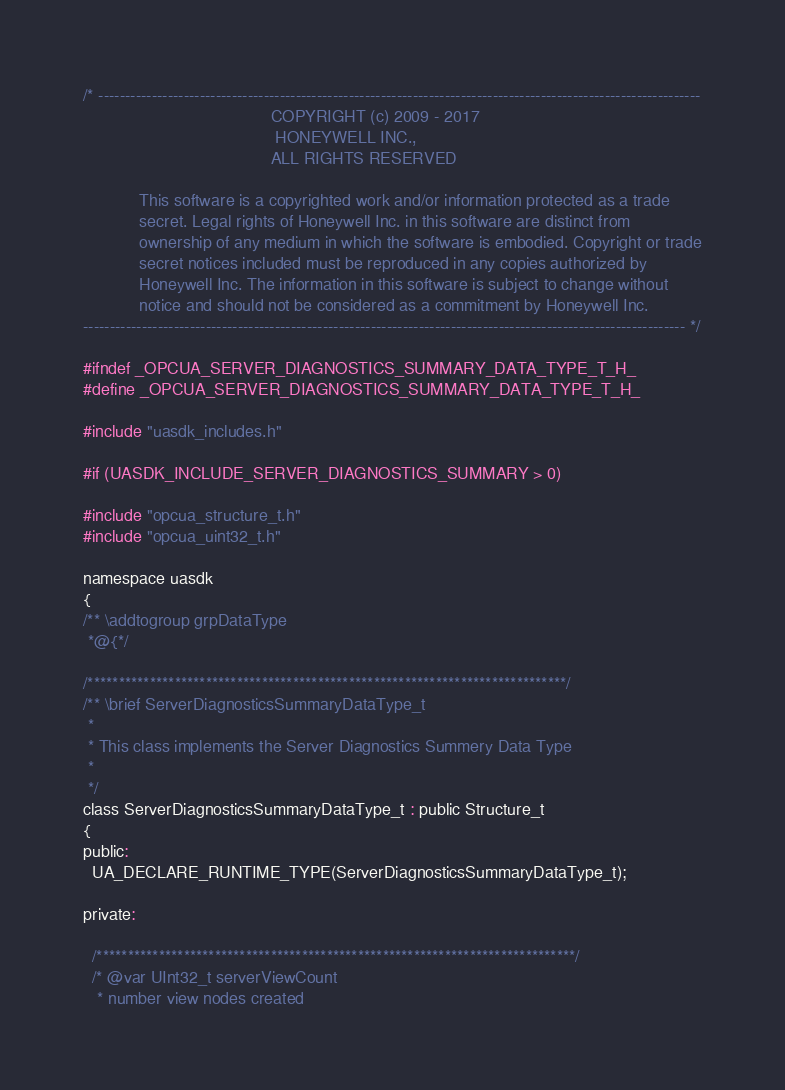Convert code to text. <code><loc_0><loc_0><loc_500><loc_500><_C_>/* -----------------------------------------------------------------------------------------------------------------
                                        COPYRIGHT (c) 2009 - 2017
                                         HONEYWELL INC.,
                                        ALL RIGHTS RESERVED

            This software is a copyrighted work and/or information protected as a trade
            secret. Legal rights of Honeywell Inc. in this software are distinct from
            ownership of any medium in which the software is embodied. Copyright or trade
            secret notices included must be reproduced in any copies authorized by
            Honeywell Inc. The information in this software is subject to change without
            notice and should not be considered as a commitment by Honeywell Inc.
----------------------------------------------------------------------------------------------------------------- */

#ifndef _OPCUA_SERVER_DIAGNOSTICS_SUMMARY_DATA_TYPE_T_H_
#define _OPCUA_SERVER_DIAGNOSTICS_SUMMARY_DATA_TYPE_T_H_

#include "uasdk_includes.h"

#if (UASDK_INCLUDE_SERVER_DIAGNOSTICS_SUMMARY > 0)

#include "opcua_structure_t.h"
#include "opcua_uint32_t.h"

namespace uasdk
{
/** \addtogroup grpDataType
 *@{*/

/*****************************************************************************/
/** \brief ServerDiagnosticsSummaryDataType_t
 *
 * This class implements the Server Diagnostics Summery Data Type
 *
 */
class ServerDiagnosticsSummaryDataType_t : public Structure_t
{
public:
  UA_DECLARE_RUNTIME_TYPE(ServerDiagnosticsSummaryDataType_t);

private:

  /*****************************************************************************/
  /* @var UInt32_t serverViewCount
   * number view nodes created</code> 